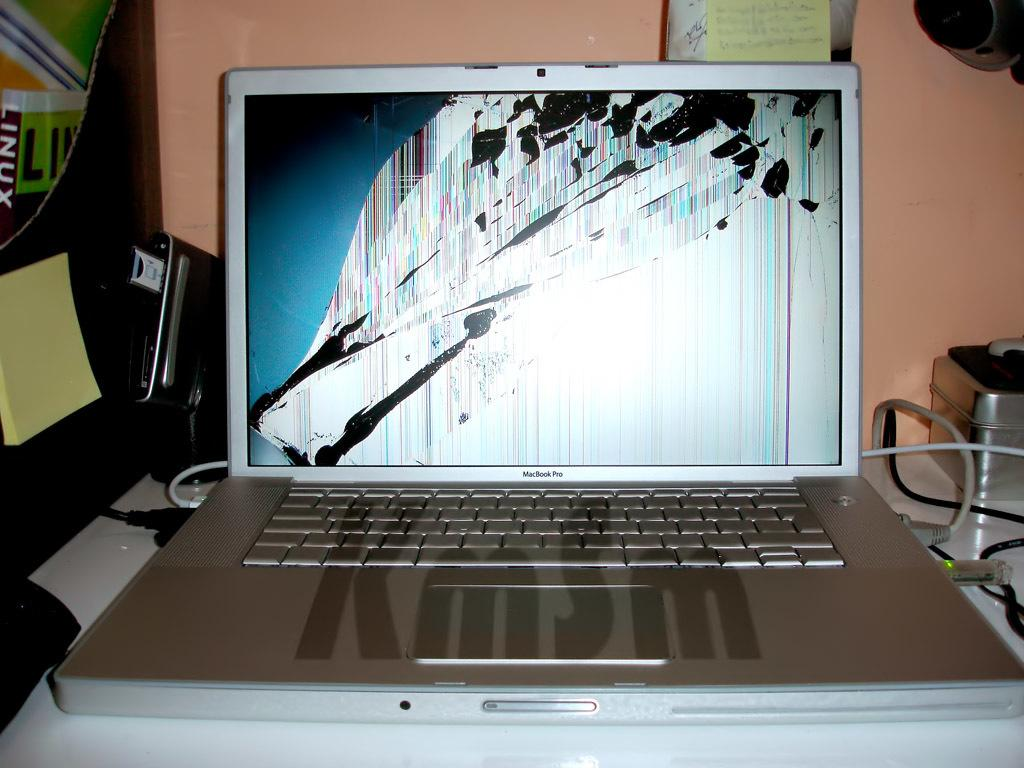<image>
Offer a succinct explanation of the picture presented. A KmSm computer is open and the screen is broken. 